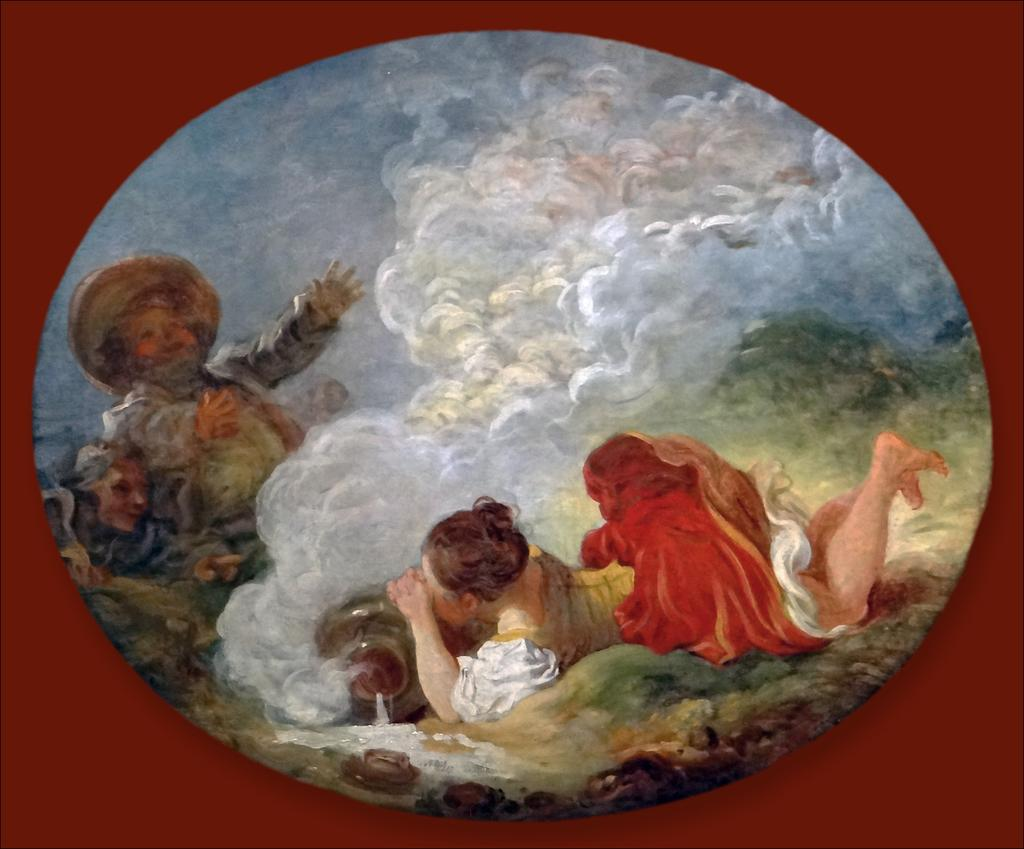What is the main subject of the image? There is a painting in the image. What is happening in the painting? The painting depicts a woman laying on the ground and a man with a hat. What is the man in the painting doing? The man in the painting is spreading his hands and standing. What type of poison is the man in the painting using to harm the woman? There is no poison present in the painting; it depicts a man standing and spreading his hands, while a woman lays on the ground. Can you tell me where the kettle is located in the painting? There is no kettle present in the painting; it only features a woman laying on the ground and a man with a hat. 